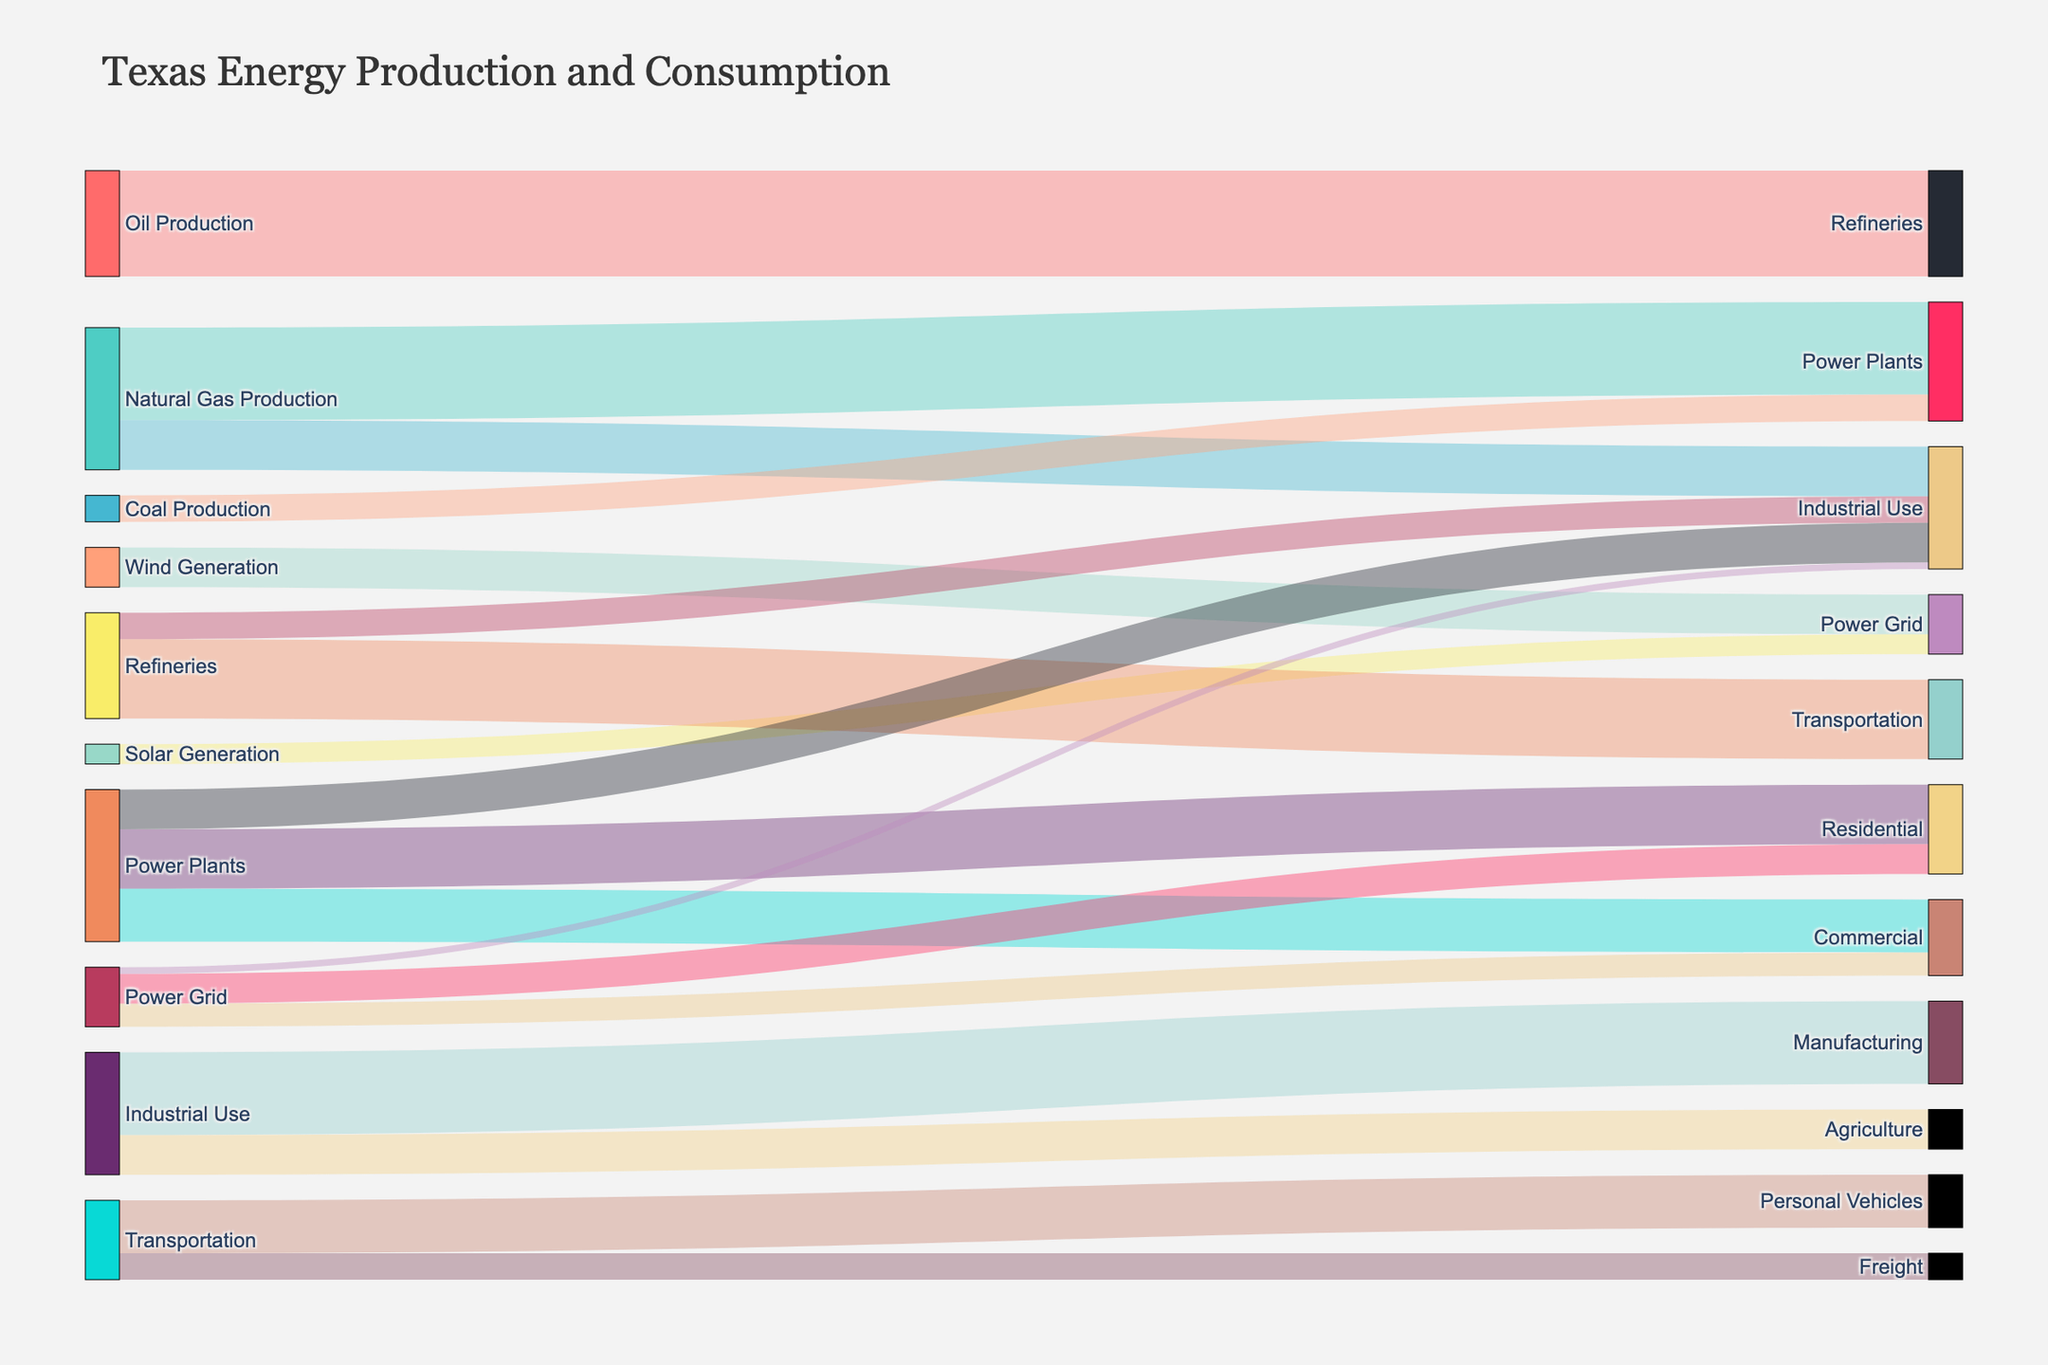Which source has the highest energy production value? Look for the source with the highest value contribution. Oil Production has the highest value of 3200.
Answer: Oil Production Which sector consumes the most energy from Power Plants? Compare the values connected from Power Plants to different sectors. Residential is the highest with 1800.
Answer: Residential What is the second largest source of energy production? Compare all the source values and pick the second highest. Natural Gas Production is second with 2800.
Answer: Natural Gas Production What is the total energy value consumed by the Industrial Use sector? Sum up the values flowing into Industrial Use: 1500 (Natural Gas Production) + 800 (Refineries) + 1200 (Power Plants) + 200 (Power Grid). The total is 3700.
Answer: 3700 Which sector receives energy from Wind Generation? Identify the target connected to Wind Generation. The target is Power Grid with the value 1200.
Answer: Power Grid What is the difference between energy supplied to Transportation from Refineries compared to that supplied from Power Plants? The energy supplied from Refineries to Transportation is 2400 and from Power Plants to Transportation is not directly available (0). The difference is 2400 - 0 = 2400.
Answer: 2400 Which source provides energy to the most number of distinct targets? Count distinct targets for each source. Natural Gas Production has three distinct targets: Power Plants, Industrial Use, Power Grid.
Answer: Natural Gas Production How many different sources supply energy to the Power Grid? Identify sources linked to Power Grid. Wind Generation and Solar Generation are the sources; thus there are 2.
Answer: 2 _energy production from Solar Generation_ Identify the value from Solar Generation. The value is 600.
Answer: 600 